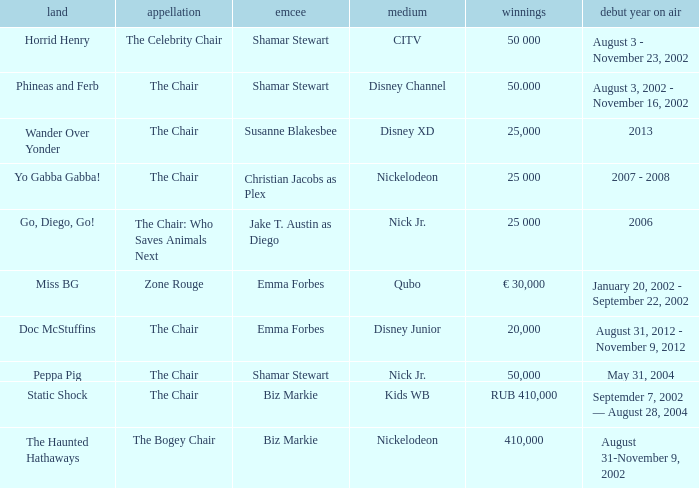What was the first year that had a prize of 50,000? May 31, 2004. 